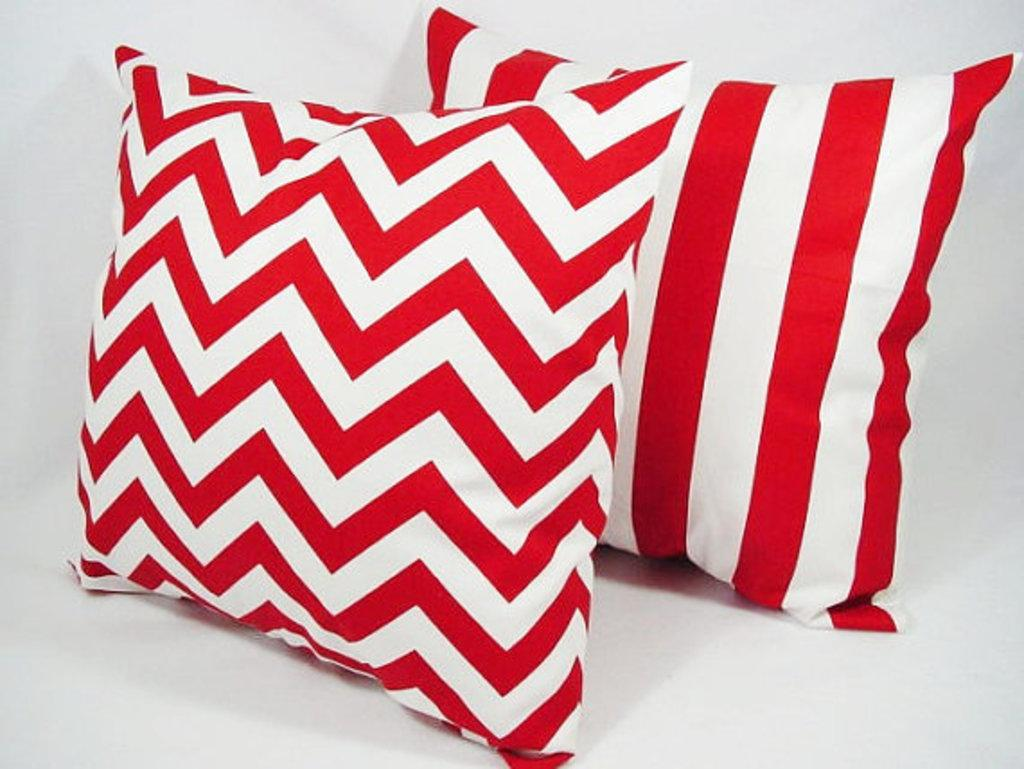How many cushions are visible in the image? There are two cushions in the image. What can be seen in the background of the image? The background of the image is white. Can you see any animals from the zoo in the image? No, there are no animals from the zoo present in the image. What type of bread is being used as a prop in the image? There is no bread present in the image. 